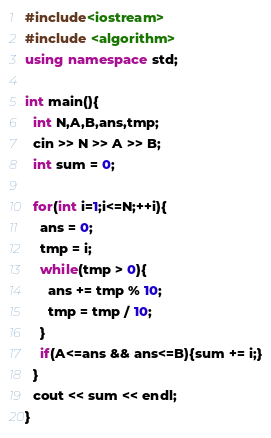Convert code to text. <code><loc_0><loc_0><loc_500><loc_500><_C++_>#include<iostream>
#include <algorithm>
using namespace std;

int main(){
  int N,A,B,ans,tmp;
  cin >> N >> A >> B;
  int sum = 0;

  for(int i=1;i<=N;++i){
    ans = 0;
    tmp = i;
    while(tmp > 0){
      ans += tmp % 10;
      tmp = tmp / 10;
    }
    if(A<=ans && ans<=B){sum += i;}
  }
  cout << sum << endl;
}</code> 